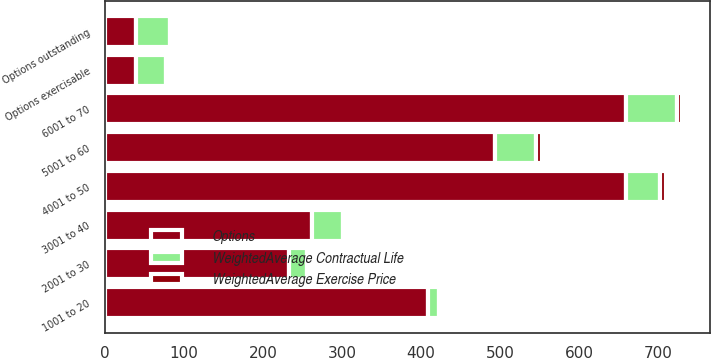Convert chart to OTSL. <chart><loc_0><loc_0><loc_500><loc_500><stacked_bar_chart><ecel><fcel>1001 to 20<fcel>2001 to 30<fcel>3001 to 40<fcel>4001 to 50<fcel>5001 to 60<fcel>6001 to 70<fcel>Options outstanding<fcel>Options exercisable<nl><fcel>WeightedAverage Exercise Price<fcel>4<fcel>5.1<fcel>3.1<fcel>6.6<fcel>6.7<fcel>5.8<fcel>5.6<fcel>4.4<nl><fcel>Options<fcel>409<fcel>233<fcel>262<fcel>659<fcel>494<fcel>660<fcel>38.5<fcel>38.5<nl><fcel>WeightedAverage Contractual Life<fcel>13<fcel>23<fcel>39<fcel>44<fcel>52<fcel>64<fcel>43<fcel>38<nl></chart> 